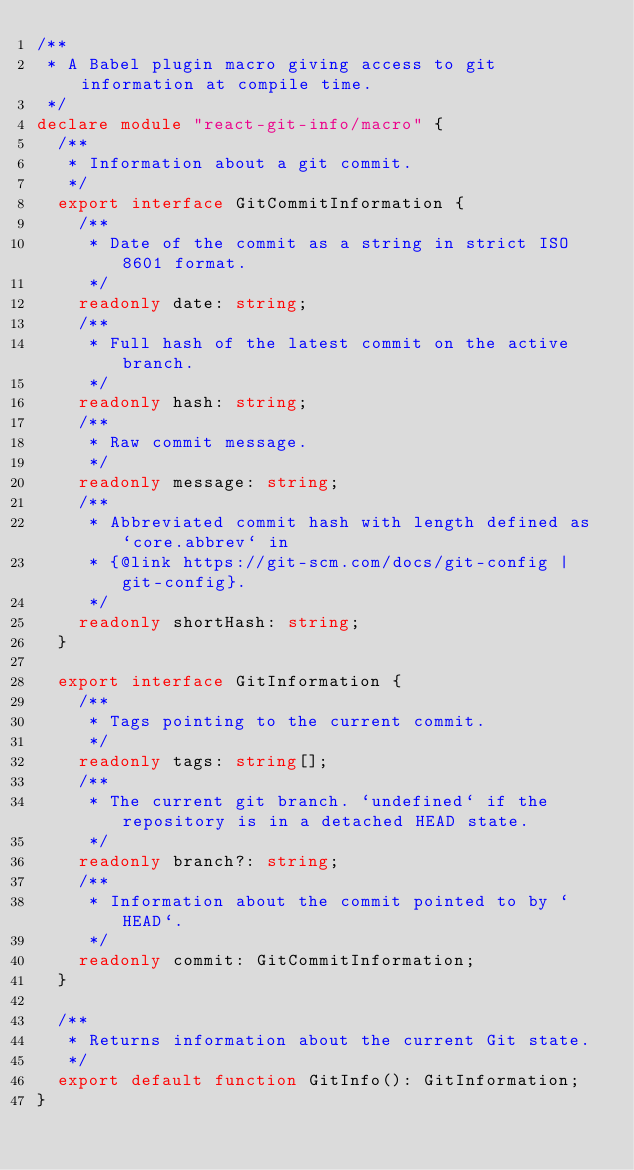<code> <loc_0><loc_0><loc_500><loc_500><_TypeScript_>/**
 * A Babel plugin macro giving access to git information at compile time.
 */
declare module "react-git-info/macro" {
  /**
   * Information about a git commit.
   */
  export interface GitCommitInformation {
    /**
     * Date of the commit as a string in strict ISO 8601 format.
     */
    readonly date: string;
    /**
     * Full hash of the latest commit on the active branch.
     */
    readonly hash: string;
    /**
     * Raw commit message.
     */
    readonly message: string;
    /**
     * Abbreviated commit hash with length defined as `core.abbrev` in
     * {@link https://git-scm.com/docs/git-config | git-config}.
     */
    readonly shortHash: string;
  }

  export interface GitInformation {
    /**
     * Tags pointing to the current commit.
     */
    readonly tags: string[];
    /**
     * The current git branch. `undefined` if the repository is in a detached HEAD state.
     */
    readonly branch?: string;
    /**
     * Information about the commit pointed to by `HEAD`.
     */
    readonly commit: GitCommitInformation;
  }

  /**
   * Returns information about the current Git state.
   */
  export default function GitInfo(): GitInformation;
}
</code> 